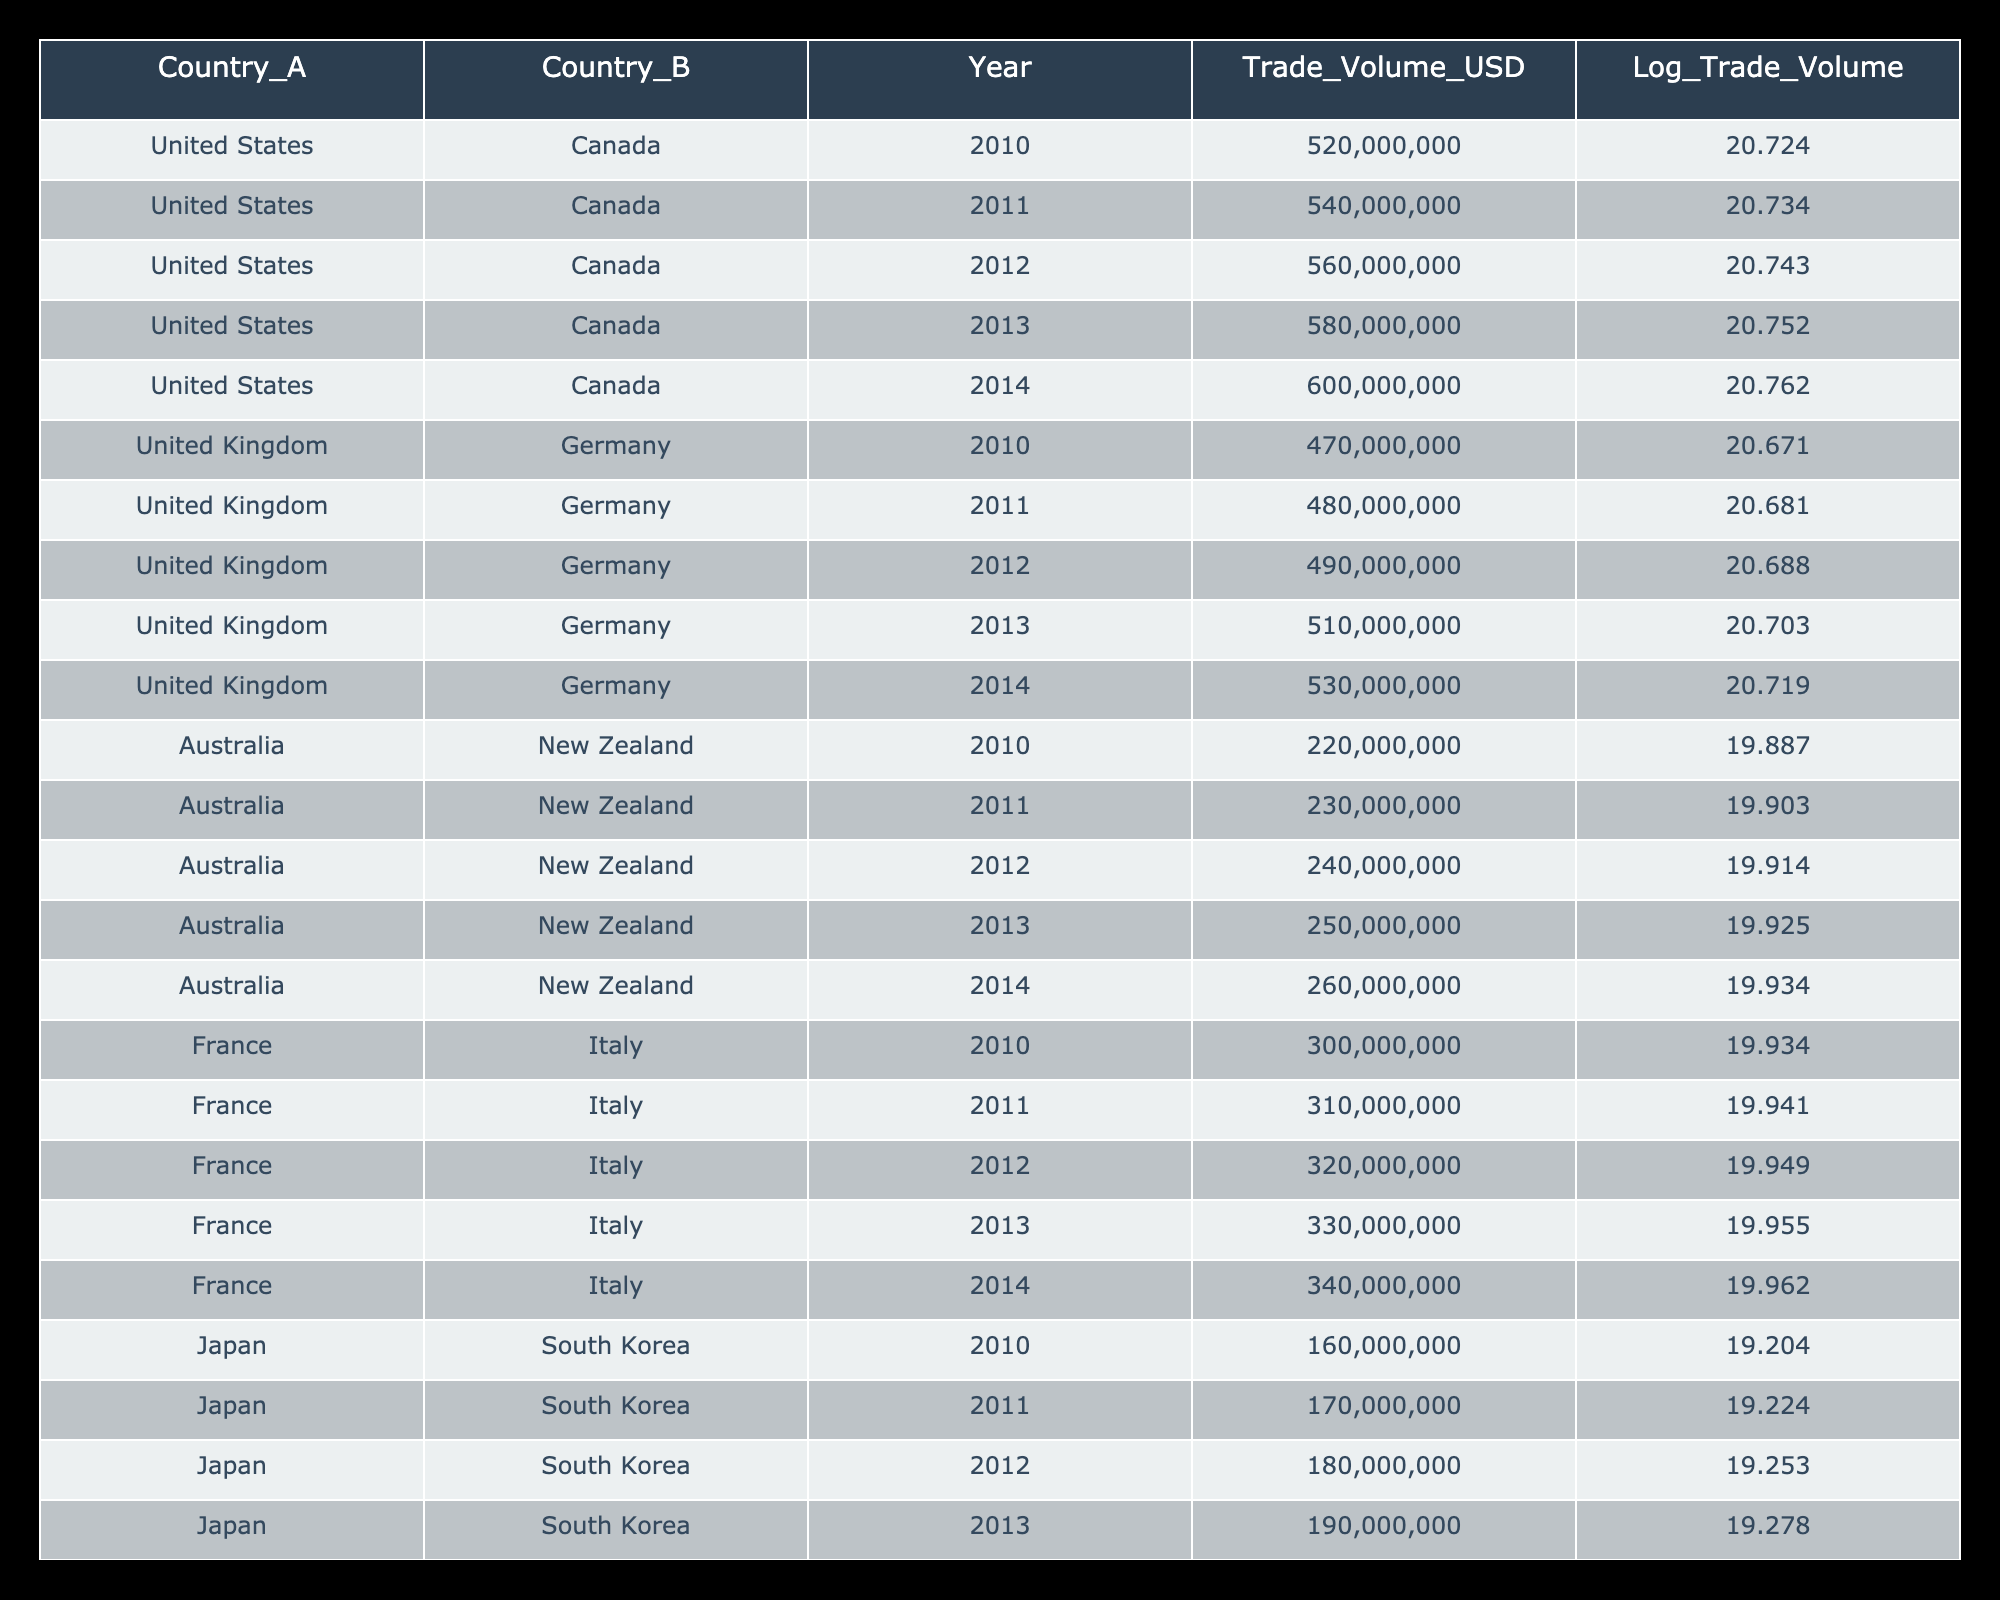What was the trade volume between the United States and Canada in 2014? Referring to the table, in the row for the year 2014 under the United States and Canada entries, the trade volume listed is 600,000,000 USD.
Answer: 600000000 What is the log trade volume for Australia and New Zealand in 2012? Looking at the row for the year 2012 under the Australia and New Zealand entries, the log trade volume shown is 19.914.
Answer: 19.914 Which country pair had the highest trade volume in 2013? In the year 2013, comparing the trade volumes, the United States and Canada had a trade volume of 580,000,000, which is higher than any other listed pair for that year.
Answer: United States & Canada What is the total trade volume for France and Italy from 2010 to 2014? To find the total trade volume from 2010 to 2014 for France and Italy, we sum the volumes: 300,000,000 + 310,000,000 + 320,000,000 + 330,000,000 + 340,000,000 = 1,600,000,000.
Answer: 1600000000 Was the trade volume between Japan and South Korea increasing every year from 2010 to 2014? By analyzing the trade volumes from the years listed, each year shows an increase: 160,000,000 (2010), 170,000,000 (2011), 180,000,000 (2012), 190,000,000 (2013), and 200,000,000 (2014). Therefore, the answer is yes.
Answer: Yes What was the average trade volume between the United Kingdom and Germany from 2011 to 2014? First, we need to find the trade volumes for those years: 480,000,000 (2011), 490,000,000 (2012), 510,000,000 (2013), and 530,000,000 (2014). Then, we add them: 480,000,000 + 490,000,000 + 510,000,000 + 530,000,000 = 2,010,000,000. Finally, dividing by 4 gives us the average: 2,010,000,000 / 4 = 502,500,000.
Answer: 502500000 Is the log trade volume for Australia and New Zealand in 2010 less than 20? Checking the log trade volume for Australia and New Zealand in 2010, we find it is 19.887, which is indeed less than 20.
Answer: Yes What was the percentage increase in trade volume for Canada and the United States from 2010 to 2014? The trade volume in 2010 was 520,000,000 and in 2014 it was 600,000,000. The increase is 600,000,000 - 520,000,000 = 80,000,000. To find the percentage increase, we divide the increase by the original amount and multiply by 100: (80,000,000 / 520,000,000) * 100 ≈ 15.38%.
Answer: 15.38% 